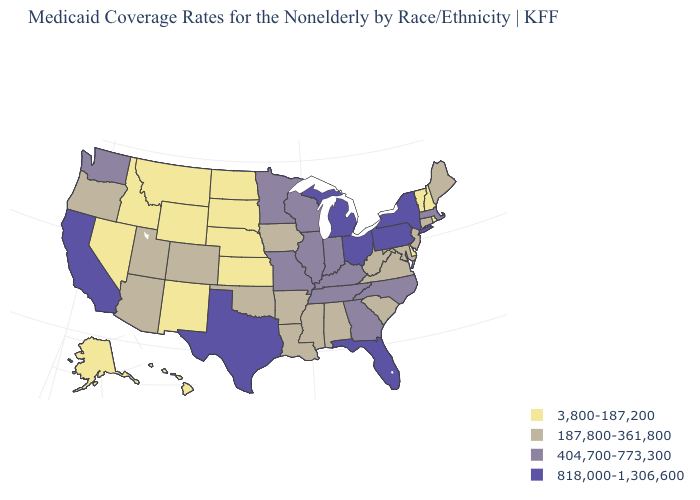What is the value of Rhode Island?
Give a very brief answer. 3,800-187,200. Does the first symbol in the legend represent the smallest category?
Concise answer only. Yes. What is the value of Kentucky?
Write a very short answer. 404,700-773,300. Does Pennsylvania have the same value as Connecticut?
Keep it brief. No. Does the map have missing data?
Answer briefly. No. What is the lowest value in the USA?
Keep it brief. 3,800-187,200. Does New Mexico have the lowest value in the West?
Short answer required. Yes. What is the lowest value in states that border California?
Quick response, please. 3,800-187,200. How many symbols are there in the legend?
Write a very short answer. 4. Among the states that border Missouri , which have the lowest value?
Be succinct. Kansas, Nebraska. Name the states that have a value in the range 404,700-773,300?
Concise answer only. Georgia, Illinois, Indiana, Kentucky, Massachusetts, Minnesota, Missouri, North Carolina, Tennessee, Washington, Wisconsin. Is the legend a continuous bar?
Short answer required. No. Is the legend a continuous bar?
Answer briefly. No. Does Ohio have the highest value in the USA?
Give a very brief answer. Yes. What is the value of Arkansas?
Be succinct. 187,800-361,800. 